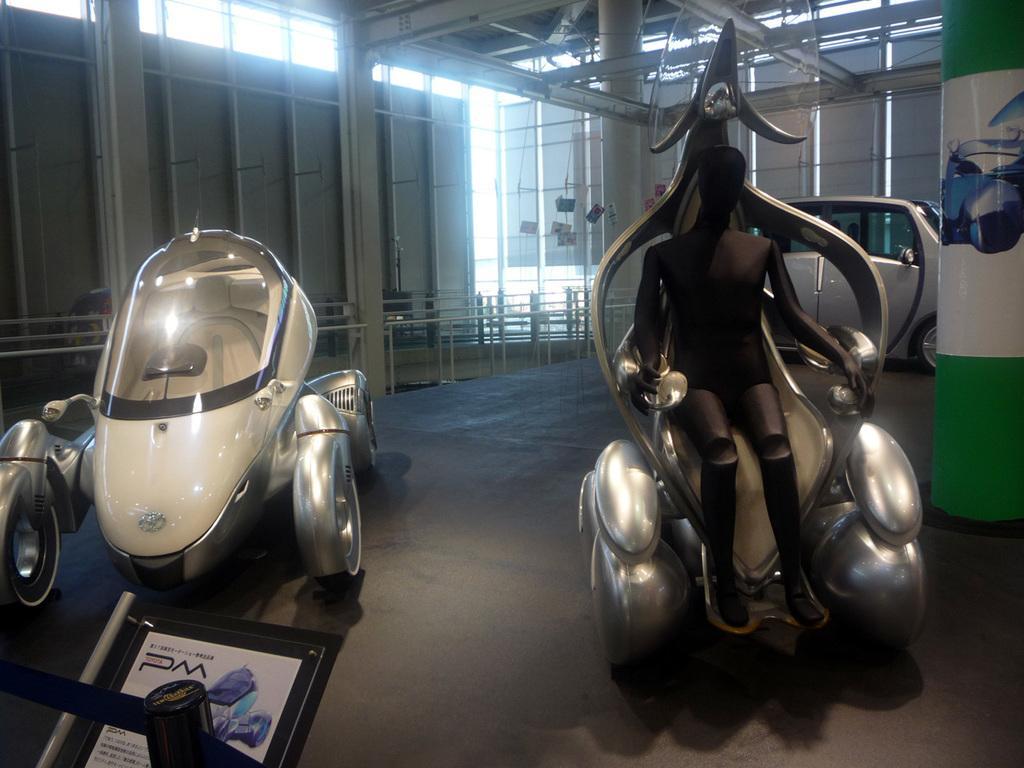How would you summarize this image in a sentence or two? This picture shows few vehicles in a room. We see lights and a name board. 